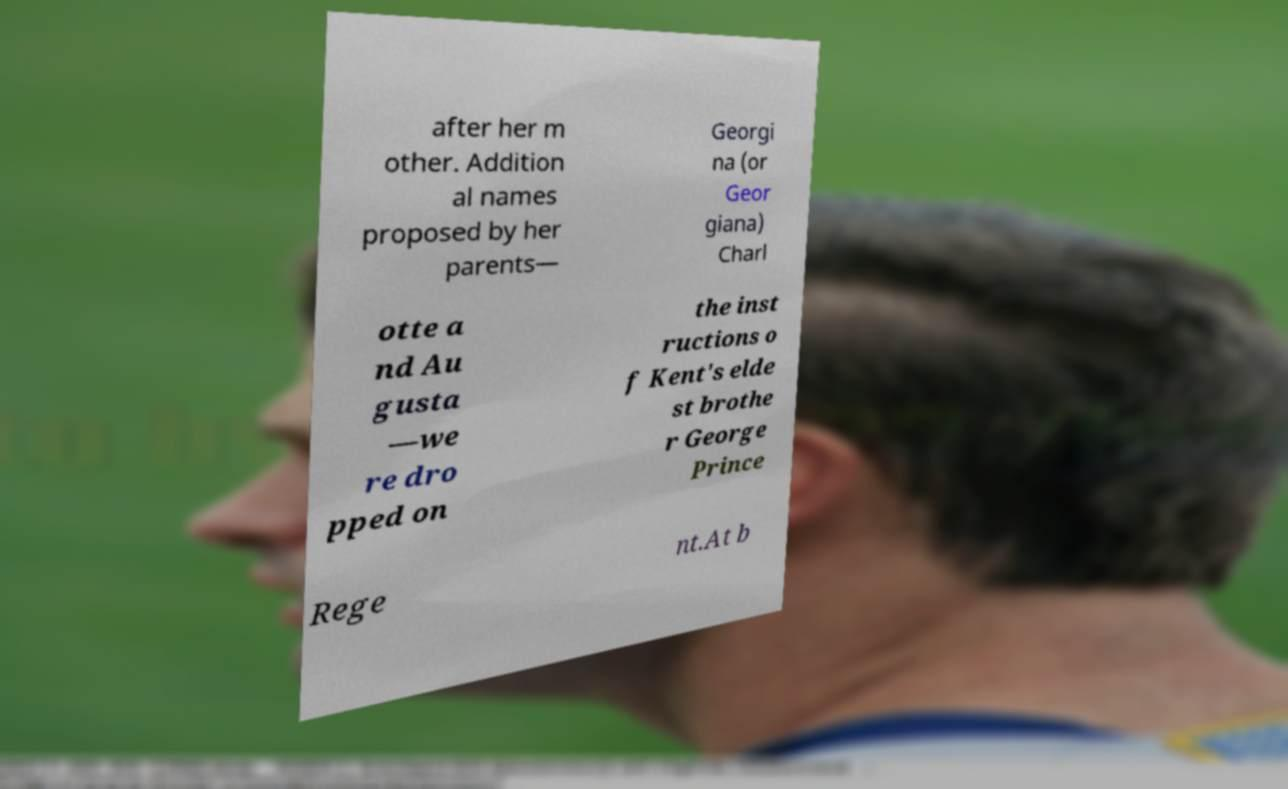Please read and relay the text visible in this image. What does it say? after her m other. Addition al names proposed by her parents— Georgi na (or Geor giana) Charl otte a nd Au gusta —we re dro pped on the inst ructions o f Kent's elde st brothe r George Prince Rege nt.At b 